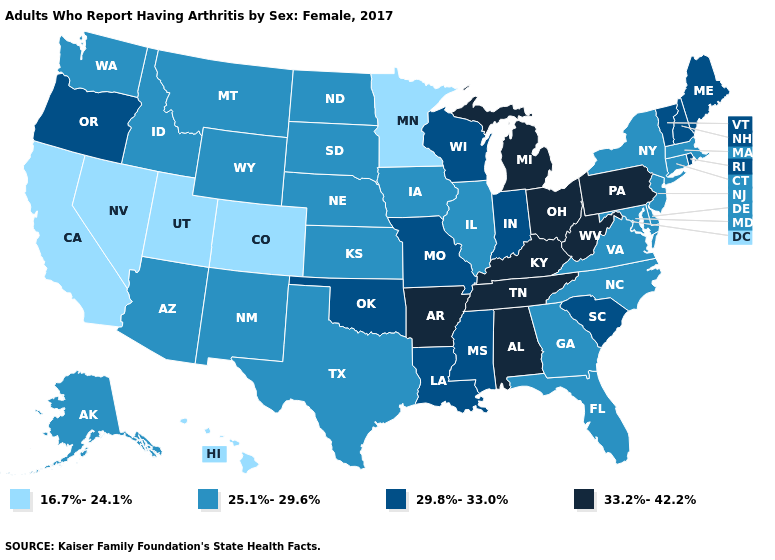Does North Carolina have the same value as New York?
Keep it brief. Yes. Among the states that border Maine , which have the highest value?
Answer briefly. New Hampshire. Name the states that have a value in the range 16.7%-24.1%?
Give a very brief answer. California, Colorado, Hawaii, Minnesota, Nevada, Utah. Name the states that have a value in the range 25.1%-29.6%?
Give a very brief answer. Alaska, Arizona, Connecticut, Delaware, Florida, Georgia, Idaho, Illinois, Iowa, Kansas, Maryland, Massachusetts, Montana, Nebraska, New Jersey, New Mexico, New York, North Carolina, North Dakota, South Dakota, Texas, Virginia, Washington, Wyoming. Does the map have missing data?
Short answer required. No. Does the map have missing data?
Short answer required. No. What is the lowest value in states that border Iowa?
Concise answer only. 16.7%-24.1%. What is the lowest value in the USA?
Keep it brief. 16.7%-24.1%. Name the states that have a value in the range 33.2%-42.2%?
Answer briefly. Alabama, Arkansas, Kentucky, Michigan, Ohio, Pennsylvania, Tennessee, West Virginia. Does the map have missing data?
Concise answer only. No. Does Ohio have a lower value than Illinois?
Be succinct. No. Does New Jersey have a higher value than Michigan?
Quick response, please. No. Among the states that border Iowa , does Wisconsin have the highest value?
Short answer required. Yes. Name the states that have a value in the range 29.8%-33.0%?
Concise answer only. Indiana, Louisiana, Maine, Mississippi, Missouri, New Hampshire, Oklahoma, Oregon, Rhode Island, South Carolina, Vermont, Wisconsin. What is the value of Mississippi?
Give a very brief answer. 29.8%-33.0%. 